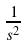<formula> <loc_0><loc_0><loc_500><loc_500>\frac { 1 } { s ^ { 2 } }</formula> 